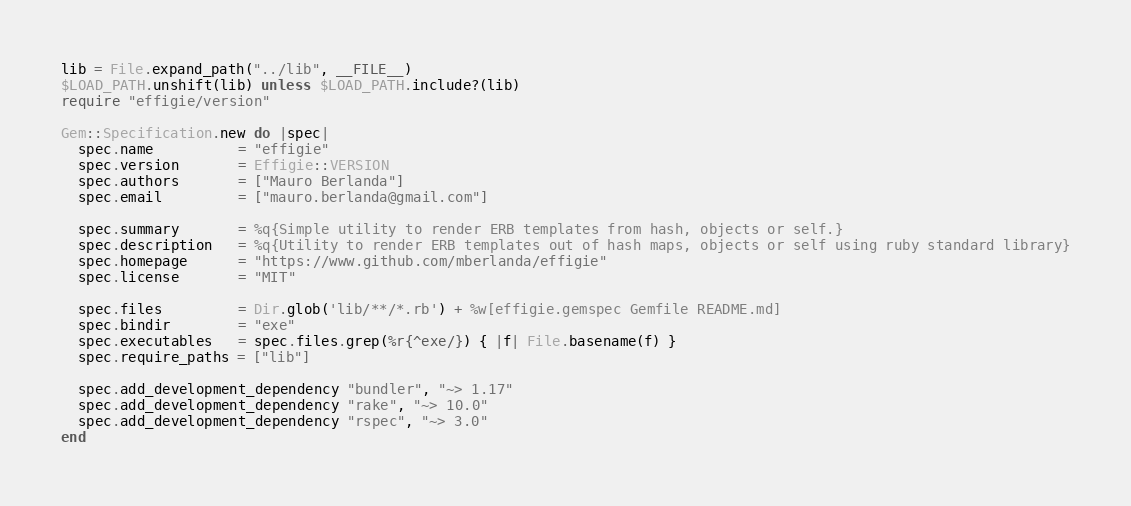Convert code to text. <code><loc_0><loc_0><loc_500><loc_500><_Ruby_>lib = File.expand_path("../lib", __FILE__)
$LOAD_PATH.unshift(lib) unless $LOAD_PATH.include?(lib)
require "effigie/version"

Gem::Specification.new do |spec|
  spec.name          = "effigie"
  spec.version       = Effigie::VERSION
  spec.authors       = ["Mauro Berlanda"]
  spec.email         = ["mauro.berlanda@gmail.com"]

  spec.summary       = %q{Simple utility to render ERB templates from hash, objects or self.}
  spec.description   = %q{Utility to render ERB templates out of hash maps, objects or self using ruby standard library}
  spec.homepage      = "https://www.github.com/mberlanda/effigie"
  spec.license       = "MIT"

  spec.files         = Dir.glob('lib/**/*.rb') + %w[effigie.gemspec Gemfile README.md]
  spec.bindir        = "exe"
  spec.executables   = spec.files.grep(%r{^exe/}) { |f| File.basename(f) }
  spec.require_paths = ["lib"]

  spec.add_development_dependency "bundler", "~> 1.17"
  spec.add_development_dependency "rake", "~> 10.0"
  spec.add_development_dependency "rspec", "~> 3.0"
end
</code> 